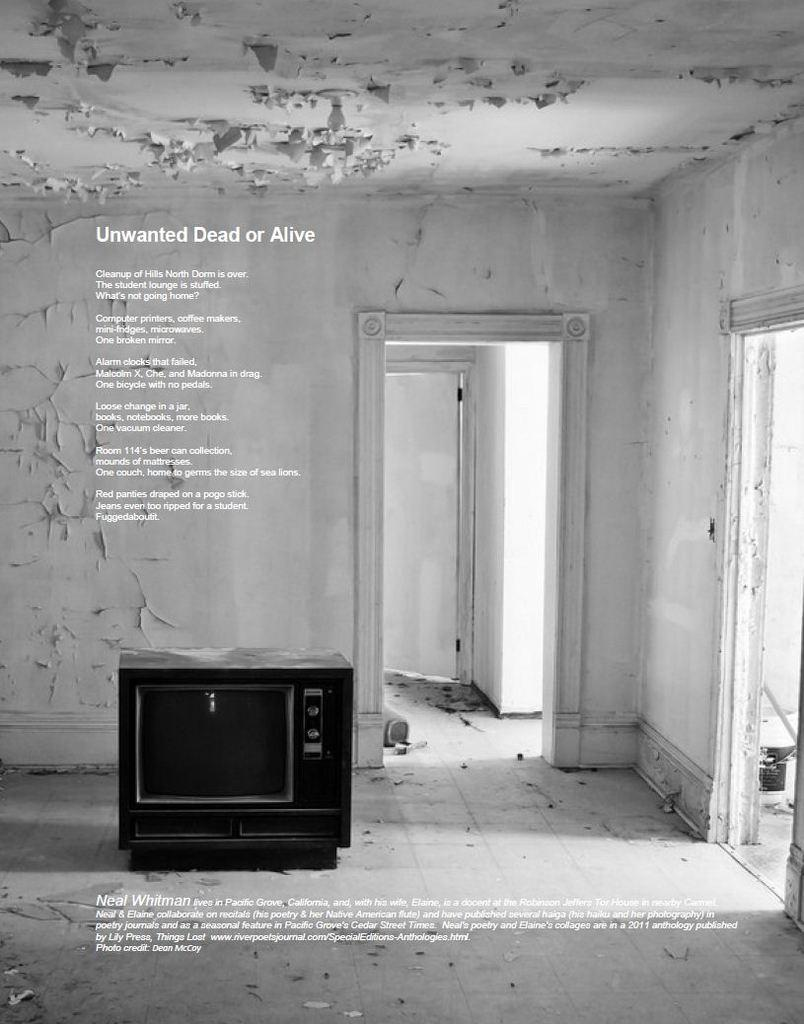<image>
Give a short and clear explanation of the subsequent image. a black and white ad with an old console tv for unwanted dead or alive 